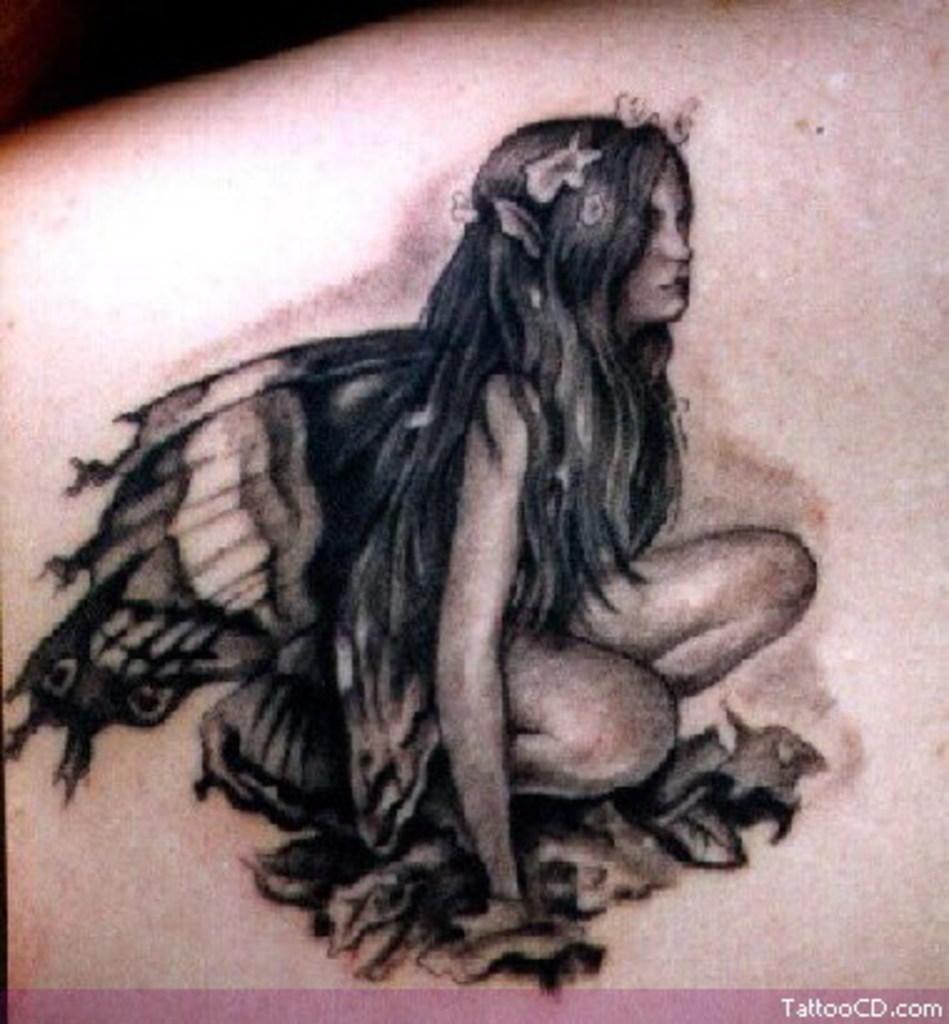In one or two sentences, can you explain what this image depicts? In this image, I can see the tattoo on the skin. This tattoo is of the woman with wings. At the bottom of the image, I can see the watermark. 